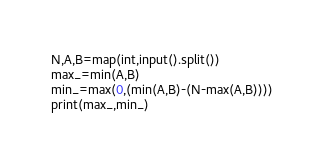Convert code to text. <code><loc_0><loc_0><loc_500><loc_500><_Python_>N,A,B=map(int,input().split())
max_=min(A,B)
min_=max(0,(min(A,B)-(N-max(A,B))))
print(max_,min_)
</code> 